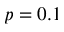Convert formula to latex. <formula><loc_0><loc_0><loc_500><loc_500>p = 0 . 1</formula> 